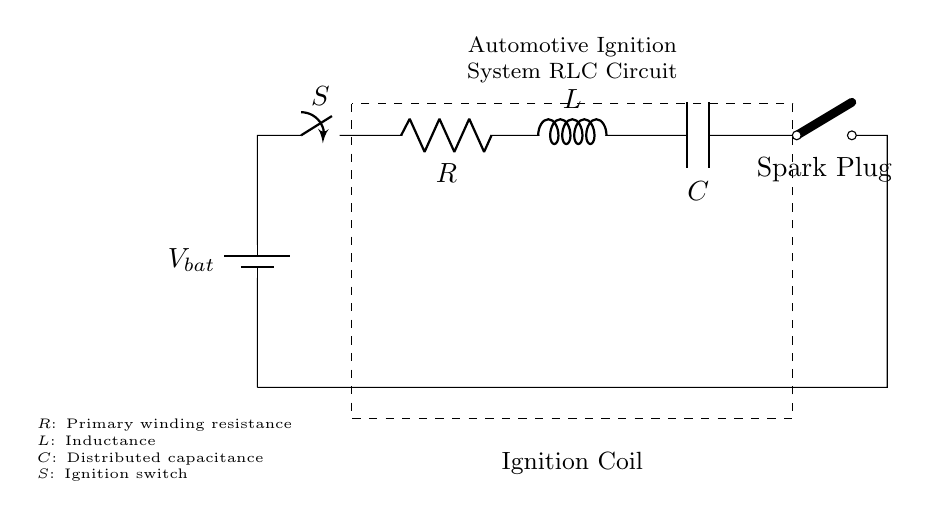What components are in the ignition system circuit? The circuit includes a battery, ignition switch, resistor, inductor, capacitor, and a spark plug. Each of these components serves a specific function in the ignition process of an automotive ignition system.
Answer: battery, ignition switch, resistor, inductor, capacitor, spark plug What does the resistor represent in this circuit? The resistor represents the primary winding resistance of the ignition coil, which affects the amount of current flowing through the circuit when the ignition switch is activated.
Answer: primary winding resistance What is the purpose of the capacitor in this circuit? The capacitor stores electrical energy in the ignition system and helps regulate voltage, improving the efficiency and timing of the spark emitted from the spark plug.
Answer: stores electrical energy What happens when the ignition switch is closed? Closing the ignition switch allows current to flow from the battery through the resistor, inductor, and capacitor to the spark plug, ultimately igniting the fuel-air mixture in the engine.
Answer: current flows, igniting fuel-air mixture How does the inductor's role affect the ignition timing? The inductor creates a magnetic field when current flows through it, and this magnetic field collapses when the switch opens, causing a high voltage which is necessary to create a spark at the spark plug. The timing of this action is crucial for optimal engine performance.
Answer: affects ignition timing by creating a spark What is the relationship between resistance and current in this circuit? According to Ohm’s Law, the resistance of the resistor will inversely affect the current in the circuit; that is, if the resistance increases, the current decreases, and vice versa. This is important for ensuring that the ignition system functions correctly.
Answer: resistance inversely affects current 